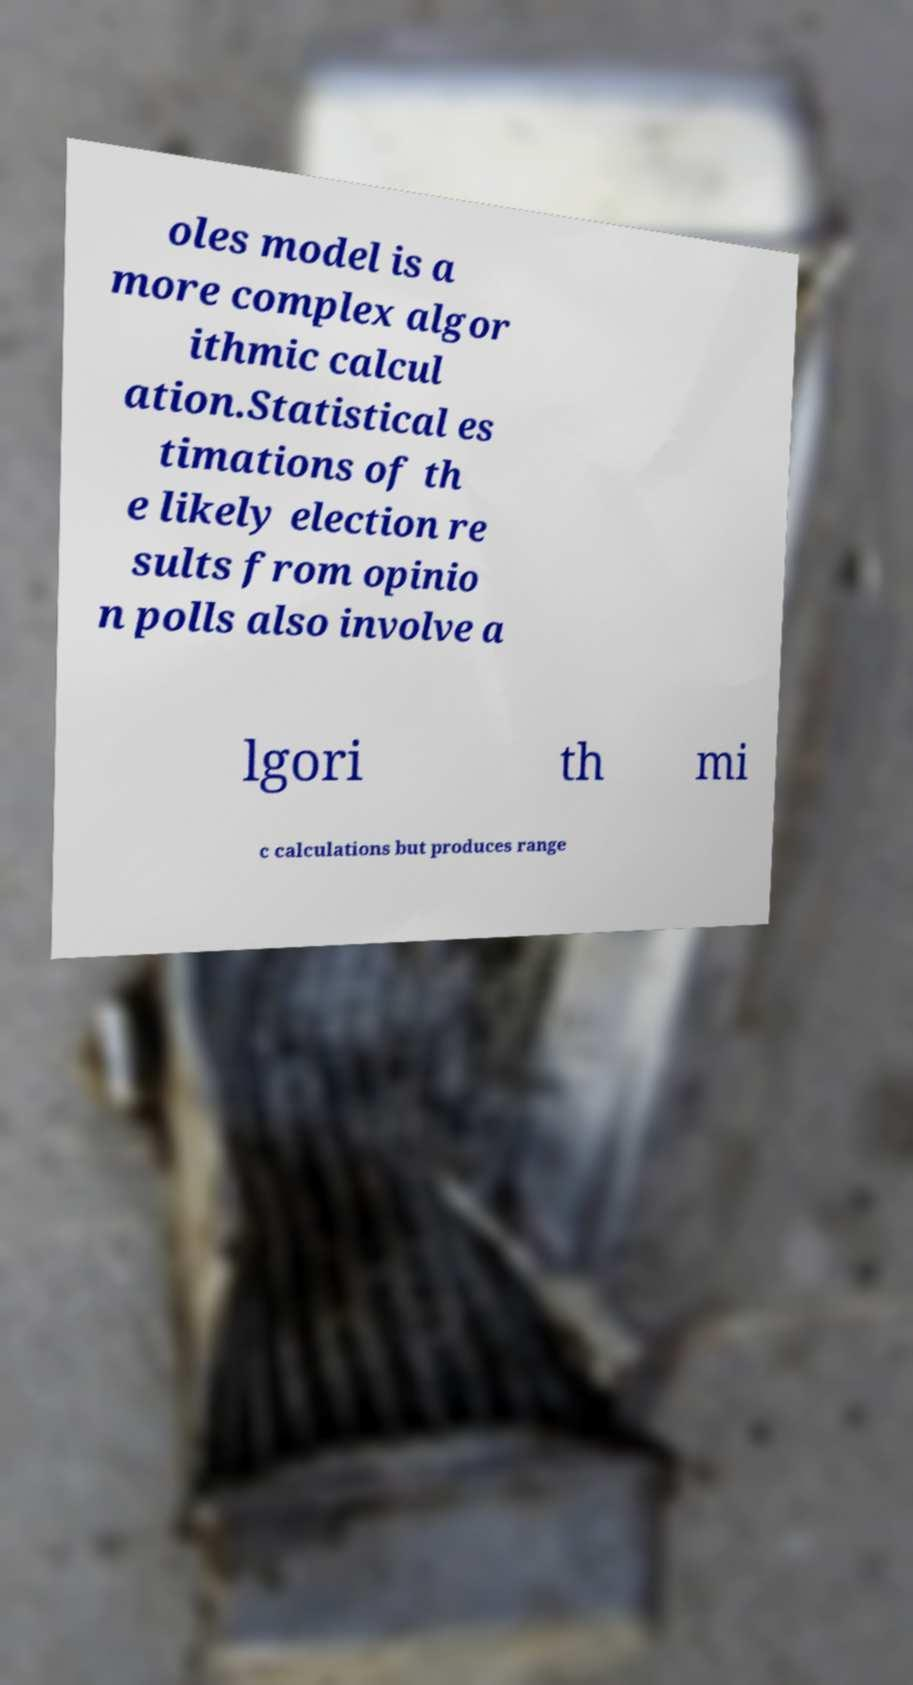Can you read and provide the text displayed in the image?This photo seems to have some interesting text. Can you extract and type it out for me? oles model is a more complex algor ithmic calcul ation.Statistical es timations of th e likely election re sults from opinio n polls also involve a lgori th mi c calculations but produces range 